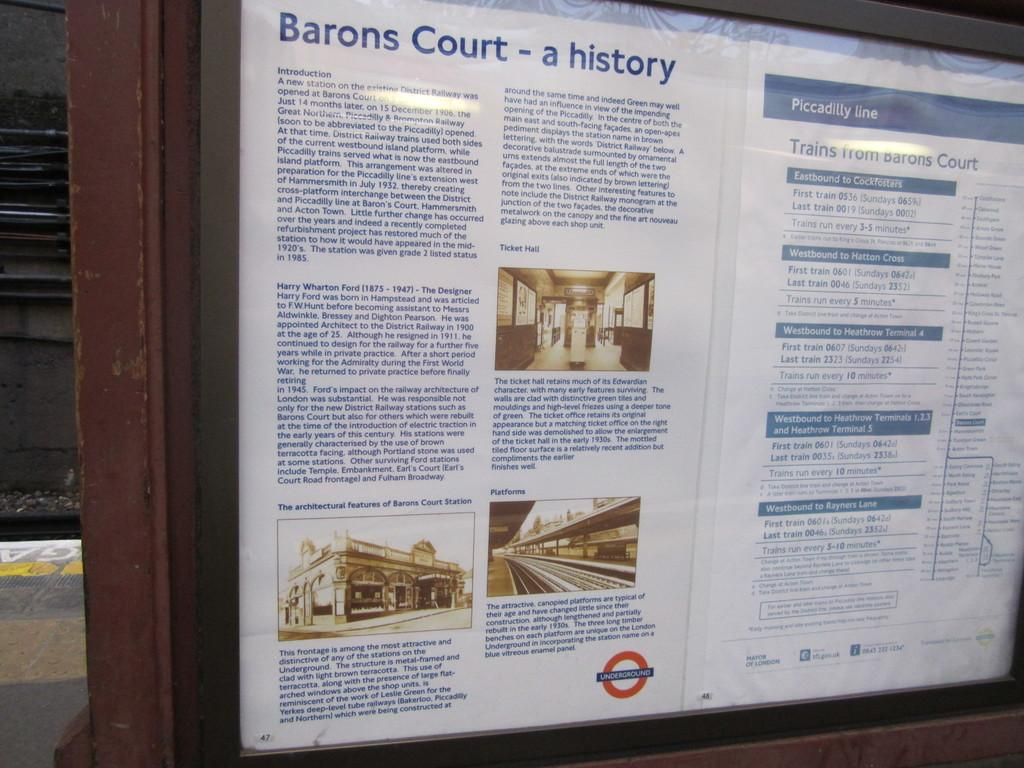<image>
Offer a succinct explanation of the picture presented. display showing a history of barons court next to a listing of times for the piccadilly line 